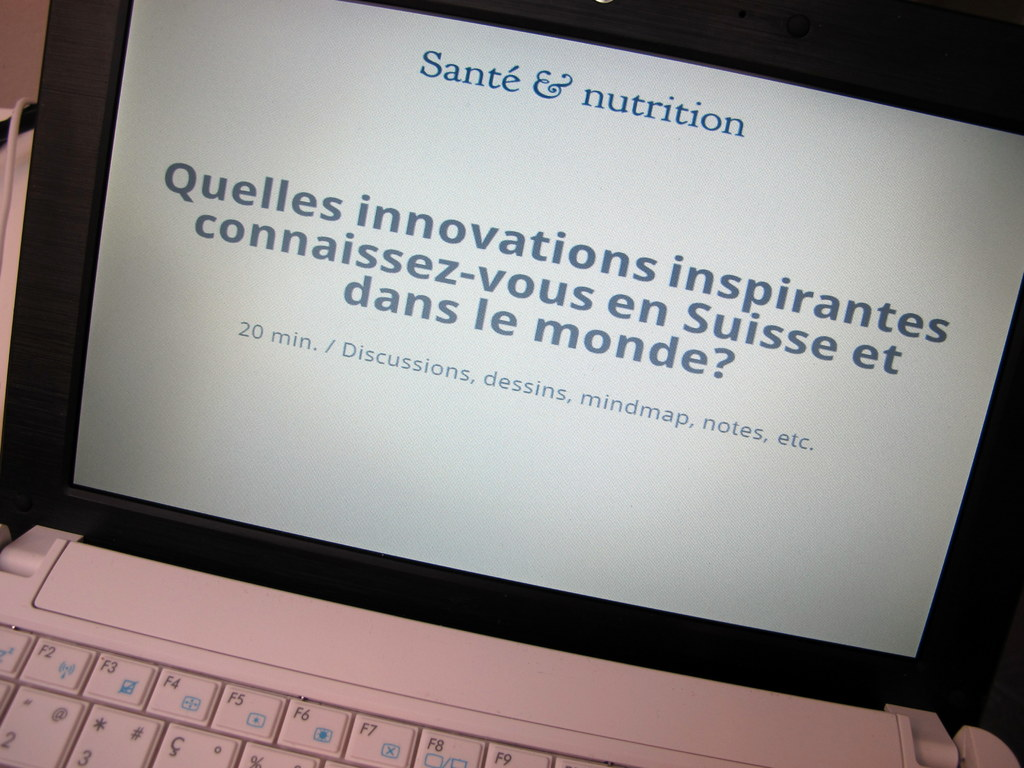Can you suggest methods or activities that could enhance the engagement of participants during this presentation? To boost engagement, the presenter could incorporate interactive polls, real-time Q&A sessions through digital platforms, and group brainstorming activities. Utilizing multimodal resources like videos or infographics could also help illustrate complex topics more vividly. Encouraging participants to share personal experiences or case studies related to health and nutrition innovations could make the session more relatable and enriching. 